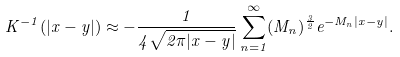<formula> <loc_0><loc_0><loc_500><loc_500>K ^ { - 1 } ( | x - y | ) \approx - \frac { 1 } { 4 \sqrt { 2 \pi | x - y | } } \sum _ { n = 1 } ^ { \infty } ( M _ { n } ) ^ { \frac { 3 } { 2 } } e ^ { - M _ { n } | x - y | } .</formula> 